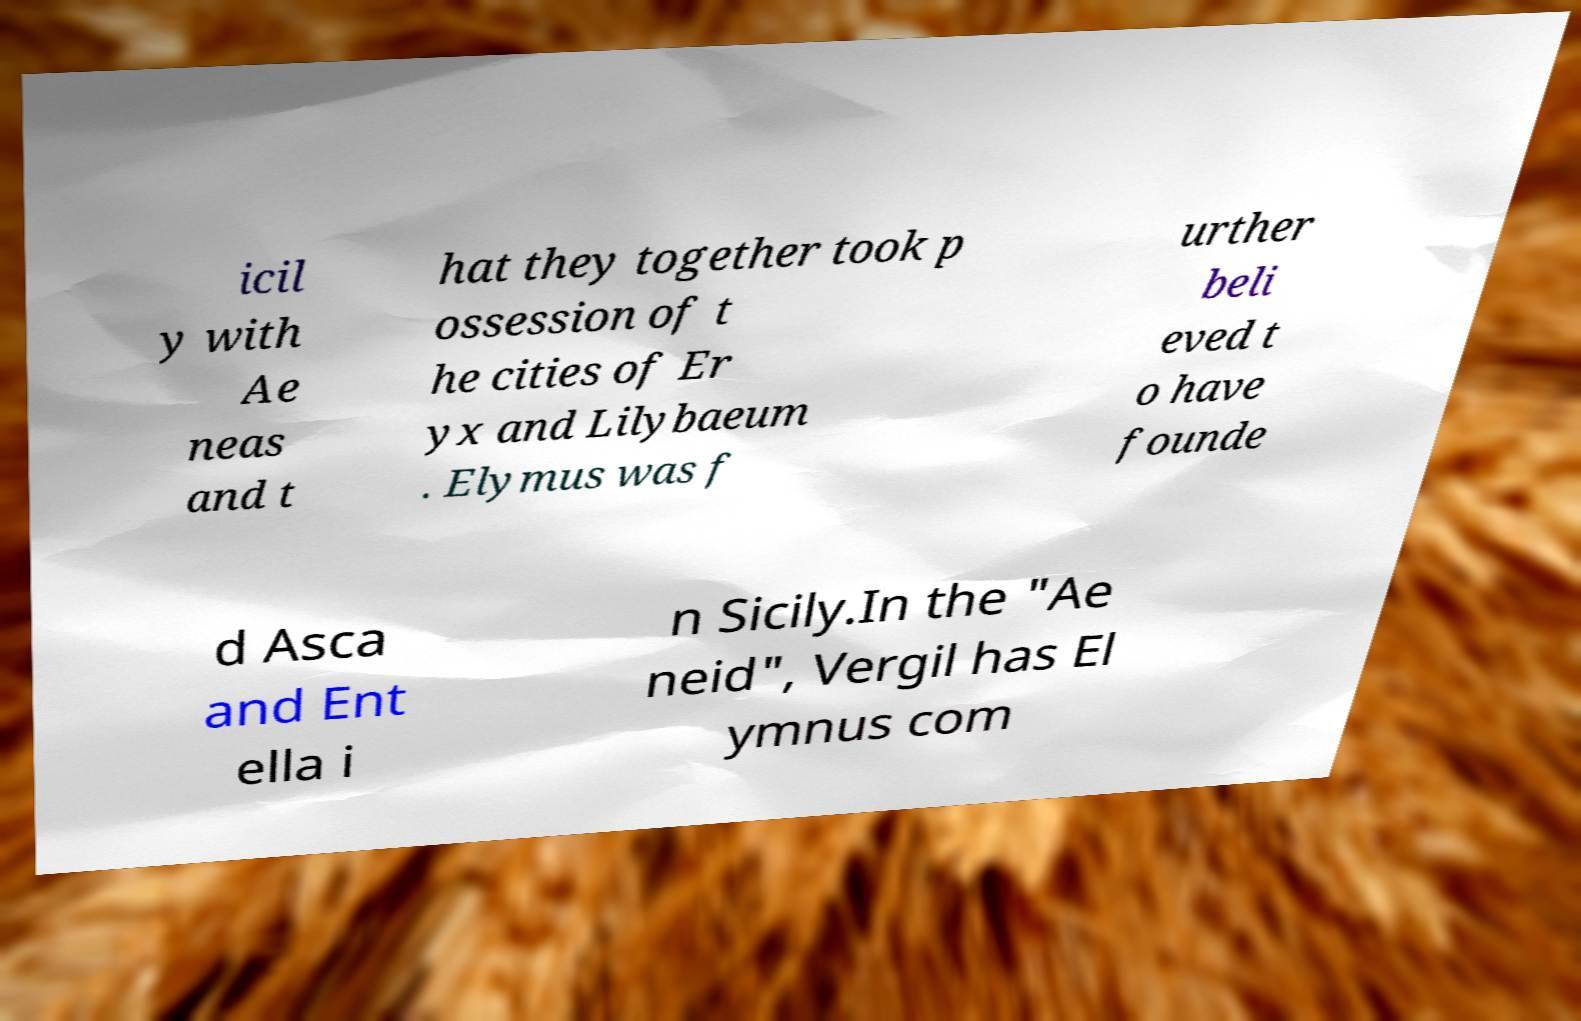Please read and relay the text visible in this image. What does it say? icil y with Ae neas and t hat they together took p ossession of t he cities of Er yx and Lilybaeum . Elymus was f urther beli eved t o have founde d Asca and Ent ella i n Sicily.In the "Ae neid", Vergil has El ymnus com 